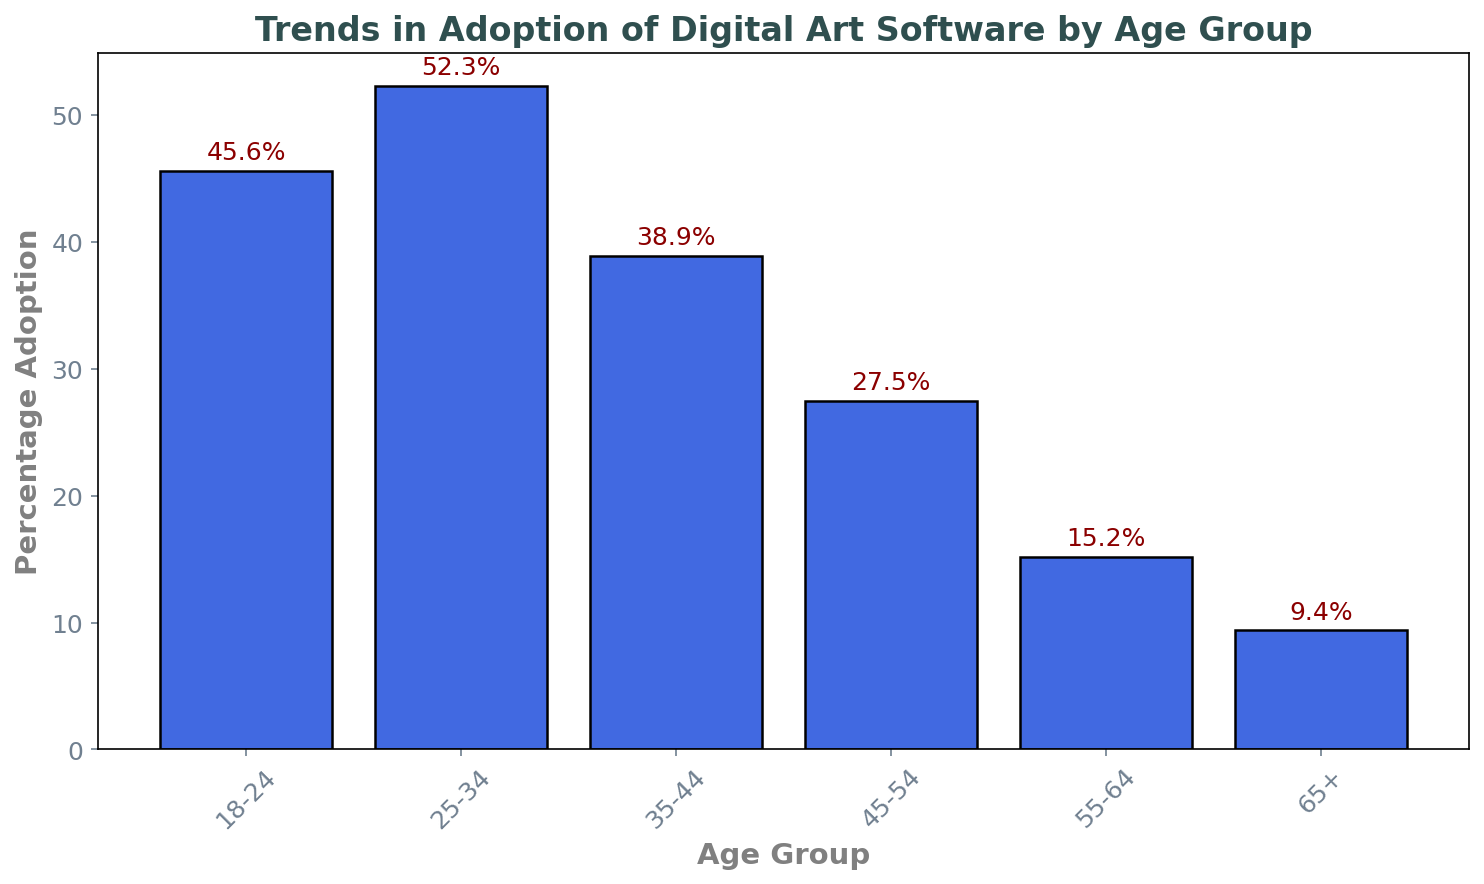Which age group has the highest adoption of digital art software? Looking at the bar chart, the height of the bar representing the 25-34 age group is the tallest. This indicates that this age group has the highest adoption percentage.
Answer: 25-34 Which age group has the lowest adoption of digital art software? Observing the bars on the chart, the bar for the 65+ age group is the shortest, showing that this group has the lowest adoption percentage.
Answer: 65+ What is the difference in adoption percentage between the 18-24 and 45-54 age groups? The adoption percentage for the 18-24 age group is 45.6%, and for the 45-54 age group, it is 27.5%. Subtracting these, 45.6% - 27.5% gives a difference of 18.1%.
Answer: 18.1% Which two consecutive age groups have the biggest drop in adoption percentage? Comparing the drops between adjacent age groups: from 25-34 to 35-44 is 52.3% - 38.9% (13.4%), from 35-44 to 45-54 is 38.9% - 27.5% (11.4%), from 45-54 to 55-64 is 27.5% - 15.2% (12.3%), and from 55-64 to 65+ is 15.2% - 9.4% (5.8%). The biggest drop is between 25-34 and 35-44 (13.4%).
Answer: 25-34 to 35-44 What’s the average adoption percentage across all age groups? Adding the percentages (45.6 + 52.3 + 38.9 + 27.5 + 15.2 + 9.4) and then dividing by the number of age groups (6), the average is (189.3 / 6) = 31.55%.
Answer: 31.55% Is the adoption percentage for the 35-44 age group more than twice that of the 65+ age group? The adoption percentage for the 35-44 age group is 38.9%, and for the 65+ age group, it is 9.4%. Doubling 9.4% gives 18.8%, which is less than 38.9%. Therefore, the 35-44 age group's adoption is more than twice that of the 65+ group.
Answer: Yes Which age group’s bar is nearly half the height of the 25-34 age group's bar? The height of the bar for the 25-34 age group is 52.3%. Half of this value is around 26.15%. The closest percentage to this value is the 45-54 age group with 27.5%.
Answer: 45-54 What is the total adoption percentage when combining all age groups above 45? Adding the percentages for age groups 45-54, 55-64, and 65+ gives: 27.5% + 15.2% + 9.4% = 52.1%.
Answer: 52.1% What percentage of the 18-24 age group uses digital art software compared to the 25-34 age group? The adoption percentage for the 18-24 age group is 45.6%, and for the 25-34 age group, it is 52.3%. Dividing the 18-24 percentage by the 25-34 percentage and multiplying by 100 gives (45.6 / 52.3) * 100 ≈ 87.2%.
Answer: 87.2% 